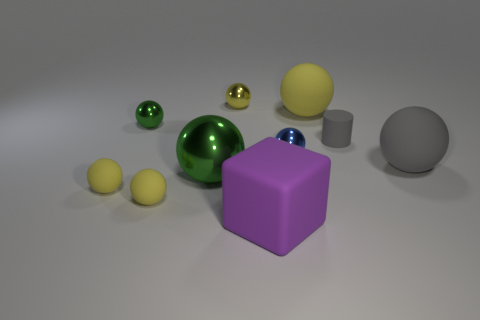Imagine this scene is part of a narrative. What story could it be telling? In the context of a narrative, this arrangement of geometric shapes could represent a serene alien landscape, where objects of different materials and colors coexist peacefully. Alternatively, this could be a metaphor for diversity and harmony within a community, with the various shapes and finishes symbolizing individual members and their unique qualities contributing to the whole. 